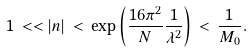Convert formula to latex. <formula><loc_0><loc_0><loc_500><loc_500>1 \, < < | n | \, < \, \exp \left ( \frac { 1 6 \pi ^ { 2 } } { N } \frac { 1 } { \lambda ^ { 2 } } \right ) \, < \, \frac { 1 } { M _ { 0 } } .</formula> 